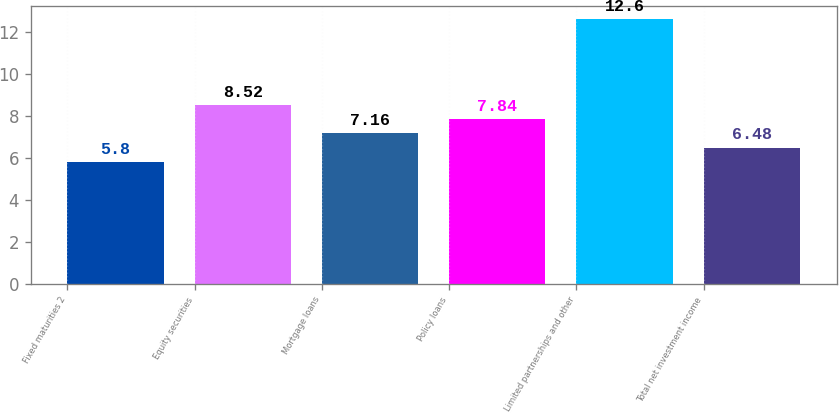Convert chart. <chart><loc_0><loc_0><loc_500><loc_500><bar_chart><fcel>Fixed maturities 2<fcel>Equity securities<fcel>Mortgage loans<fcel>Policy loans<fcel>Limited partnerships and other<fcel>Total net investment income<nl><fcel>5.8<fcel>8.52<fcel>7.16<fcel>7.84<fcel>12.6<fcel>6.48<nl></chart> 